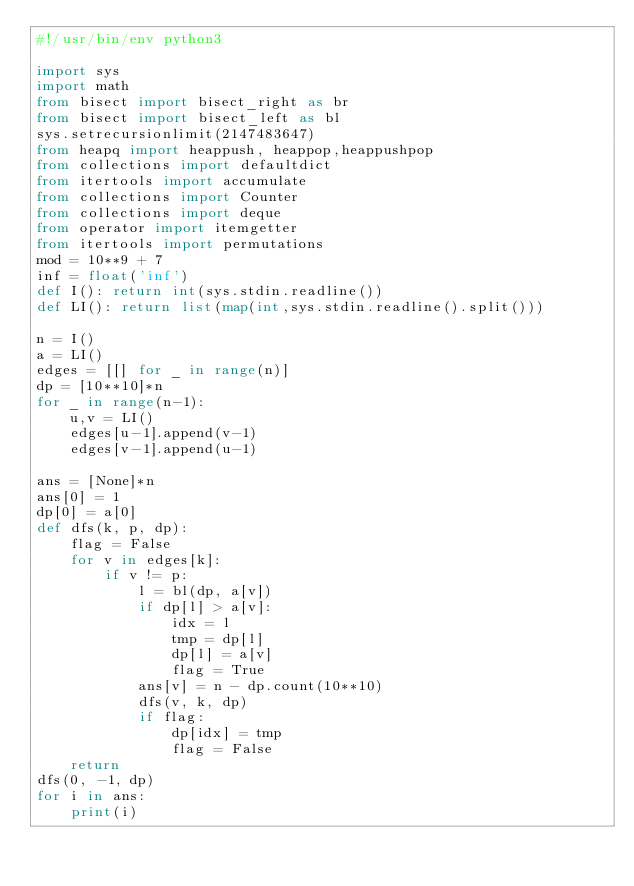<code> <loc_0><loc_0><loc_500><loc_500><_Python_>#!/usr/bin/env python3

import sys
import math
from bisect import bisect_right as br
from bisect import bisect_left as bl
sys.setrecursionlimit(2147483647)
from heapq import heappush, heappop,heappushpop
from collections import defaultdict
from itertools import accumulate
from collections import Counter
from collections import deque
from operator import itemgetter
from itertools import permutations
mod = 10**9 + 7
inf = float('inf')
def I(): return int(sys.stdin.readline())
def LI(): return list(map(int,sys.stdin.readline().split()))

n = I()
a = LI()
edges = [[] for _ in range(n)]
dp = [10**10]*n
for _ in range(n-1):
    u,v = LI()
    edges[u-1].append(v-1)
    edges[v-1].append(u-1)

ans = [None]*n
ans[0] = 1
dp[0] = a[0]
def dfs(k, p, dp):
    flag = False
    for v in edges[k]:
        if v != p:
            l = bl(dp, a[v])
            if dp[l] > a[v]:
                idx = l
                tmp = dp[l]
                dp[l] = a[v]
                flag = True
            ans[v] = n - dp.count(10**10)
            dfs(v, k, dp)
            if flag:
                dp[idx] = tmp
                flag = False
    return 
dfs(0, -1, dp)
for i in ans:
    print(i)


</code> 